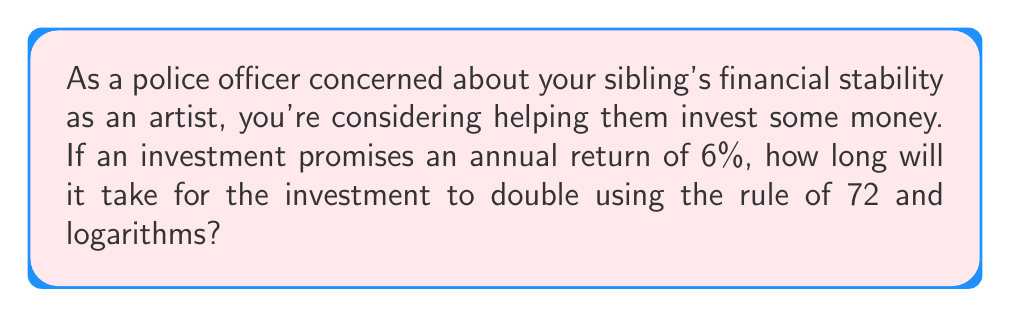Provide a solution to this math problem. Let's approach this step-by-step:

1) The Rule of 72 states that the time it takes for an investment to double is approximately equal to 72 divided by the annual return rate (as a percentage).

2) In this case, the annual return rate is 6%.

3) Using the Rule of 72, we can estimate:
   $$ \text{Time to double} \approx \frac{72}{6} = 12 \text{ years} $$

4) To calculate the exact time using logarithms, we use the compound interest formula:
   $$ A = P(1+r)^t $$
   Where A is the final amount, P is the principal (initial investment), r is the annual interest rate (as a decimal), and t is the time in years.

5) For doubling, A = 2P. Substituting this in:
   $$ 2P = P(1+0.06)^t $$

6) Dividing both sides by P:
   $$ 2 = (1.06)^t $$

7) Taking the natural logarithm of both sides:
   $$ \ln(2) = t \cdot \ln(1.06) $$

8) Solving for t:
   $$ t = \frac{\ln(2)}{\ln(1.06)} \approx 11.90 \text{ years} $$

9) This confirms that the Rule of 72 provides a very close approximation.
Answer: 11.90 years 